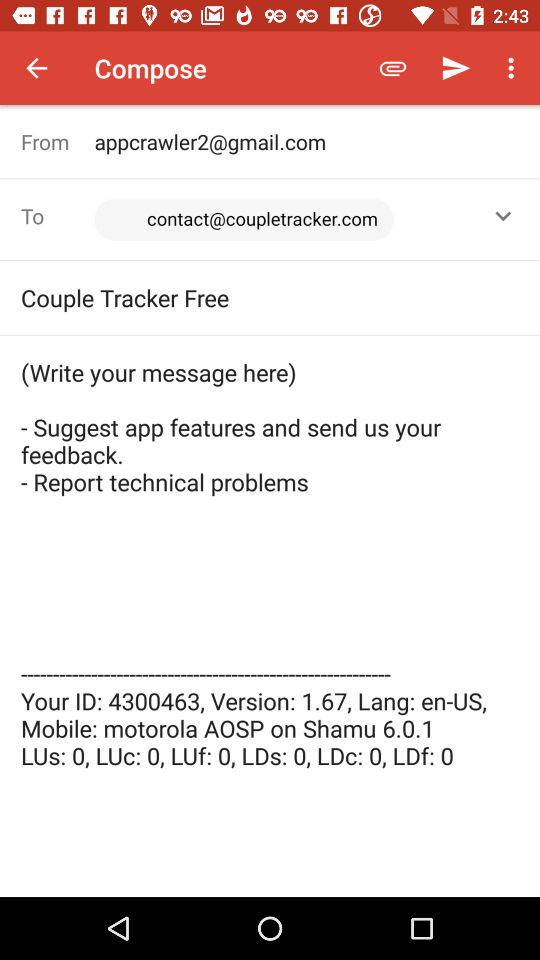What is the ID number? The ID number is 4300463. 